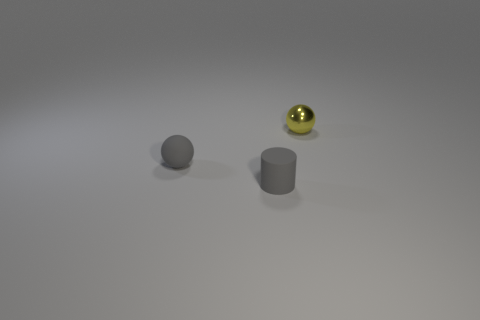Is there a rubber thing on the right side of the tiny thing that is on the right side of the matte cylinder?
Provide a short and direct response. No. What material is the tiny gray ball?
Ensure brevity in your answer.  Rubber. There is a small yellow metal sphere; are there any tiny things in front of it?
Offer a very short reply. Yes. The other object that is the same shape as the yellow thing is what size?
Your response must be concise. Small. Are there the same number of spheres that are to the right of the tiny cylinder and small shiny things right of the yellow sphere?
Provide a succinct answer. No. What number of cyan matte blocks are there?
Provide a short and direct response. 0. Are there more tiny gray balls right of the gray rubber ball than small brown metallic cylinders?
Offer a terse response. No. There is a sphere that is left of the metallic thing; what material is it?
Your response must be concise. Rubber. What is the color of the other tiny thing that is the same shape as the yellow thing?
Offer a terse response. Gray. How many small metallic things have the same color as the small shiny sphere?
Give a very brief answer. 0. 